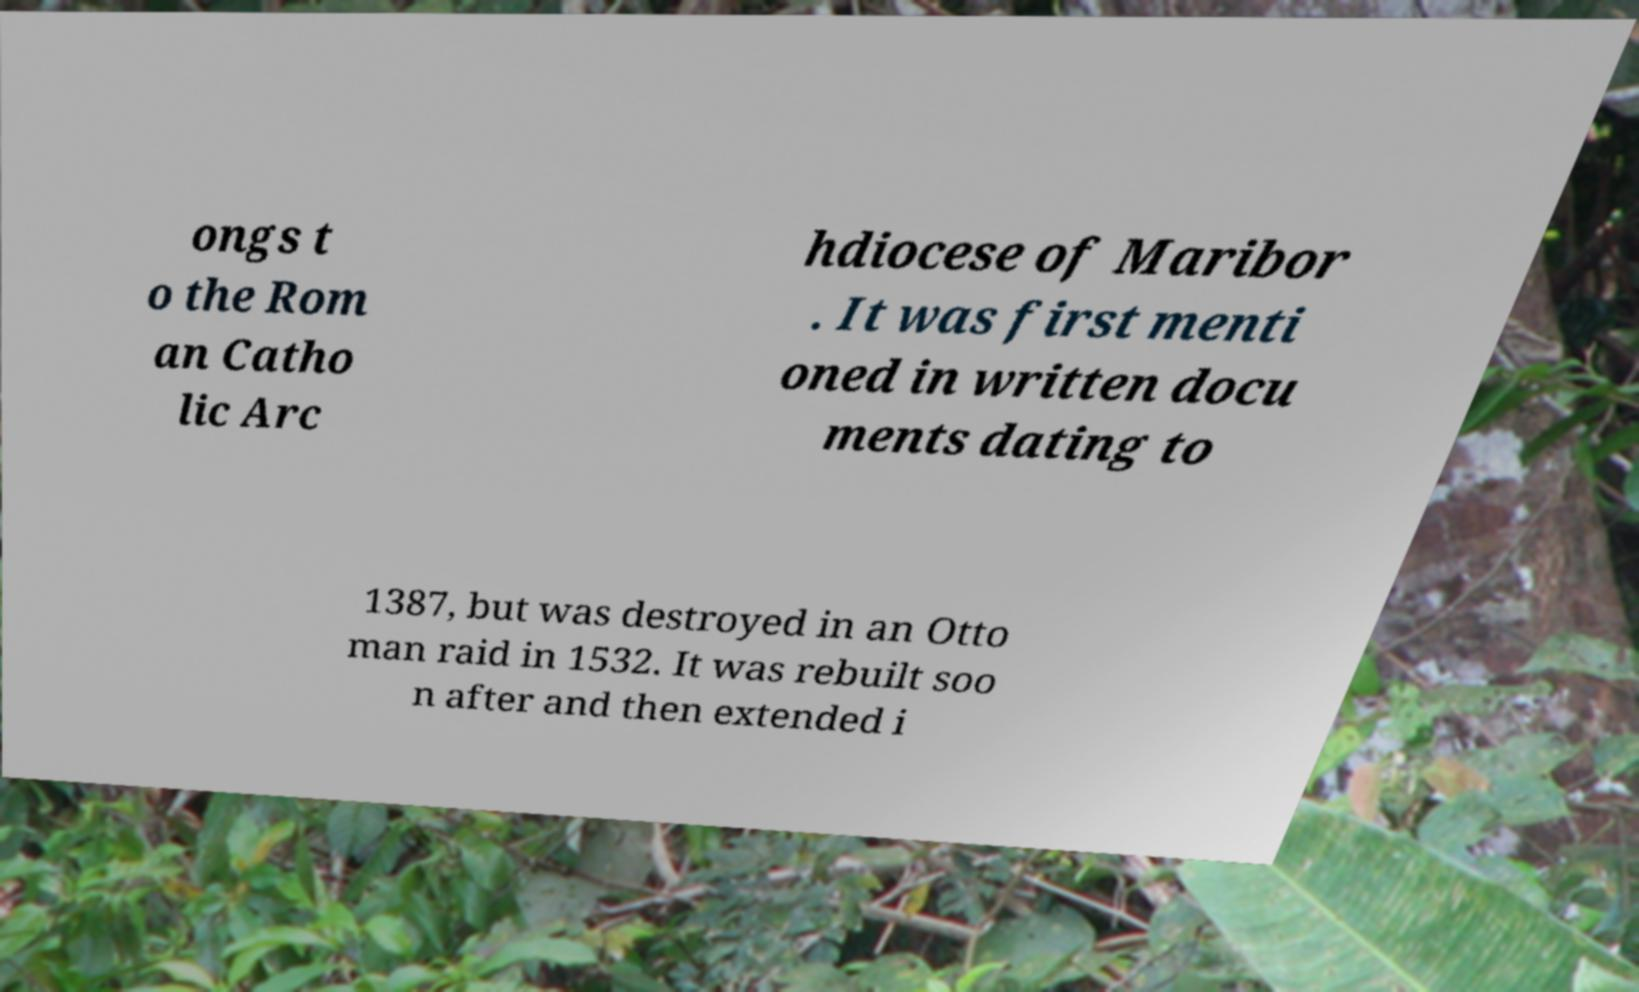Can you read and provide the text displayed in the image?This photo seems to have some interesting text. Can you extract and type it out for me? ongs t o the Rom an Catho lic Arc hdiocese of Maribor . It was first menti oned in written docu ments dating to 1387, but was destroyed in an Otto man raid in 1532. It was rebuilt soo n after and then extended i 